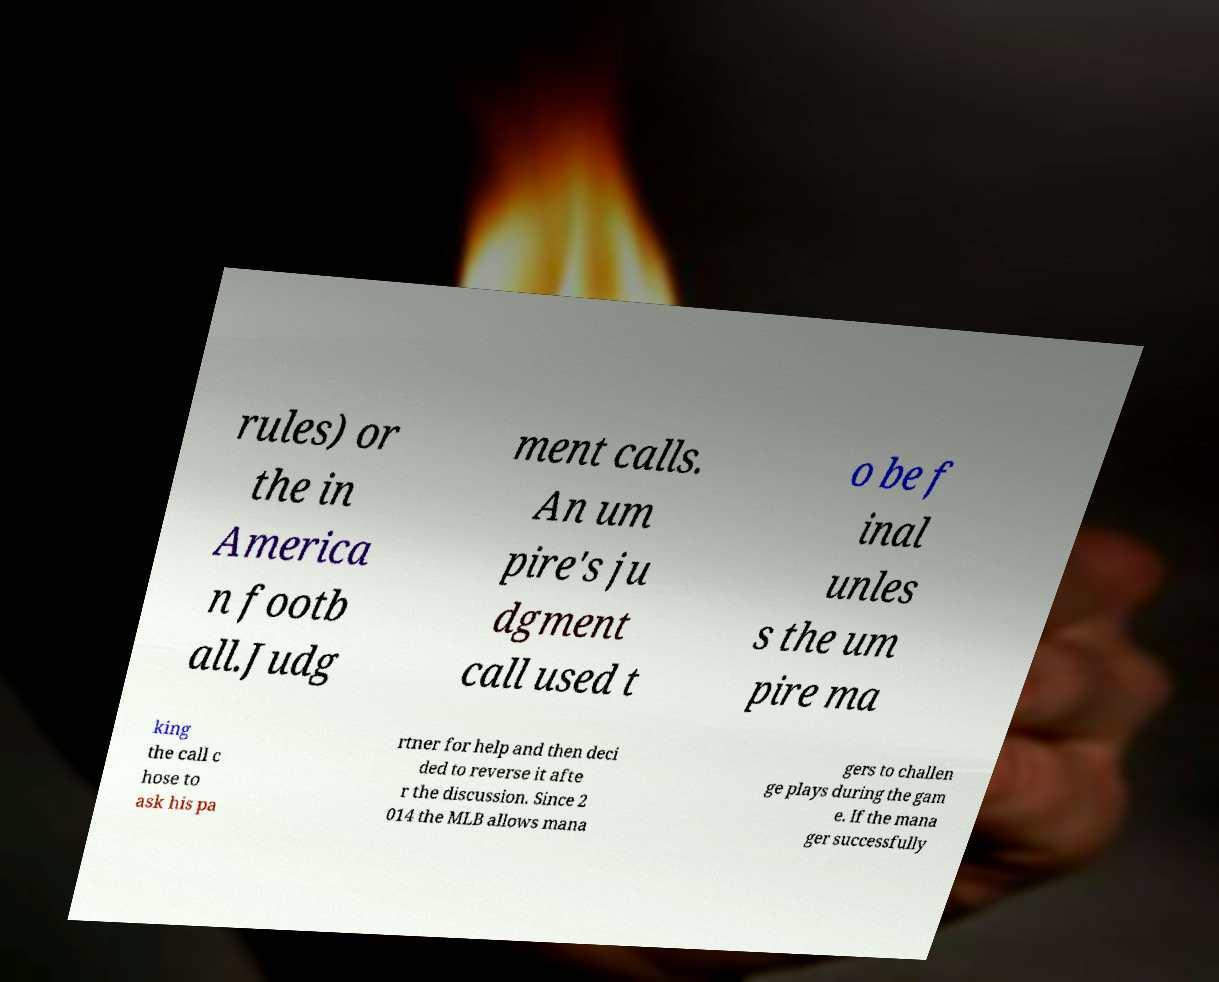I need the written content from this picture converted into text. Can you do that? rules) or the in America n footb all.Judg ment calls. An um pire's ju dgment call used t o be f inal unles s the um pire ma king the call c hose to ask his pa rtner for help and then deci ded to reverse it afte r the discussion. Since 2 014 the MLB allows mana gers to challen ge plays during the gam e. If the mana ger successfully 